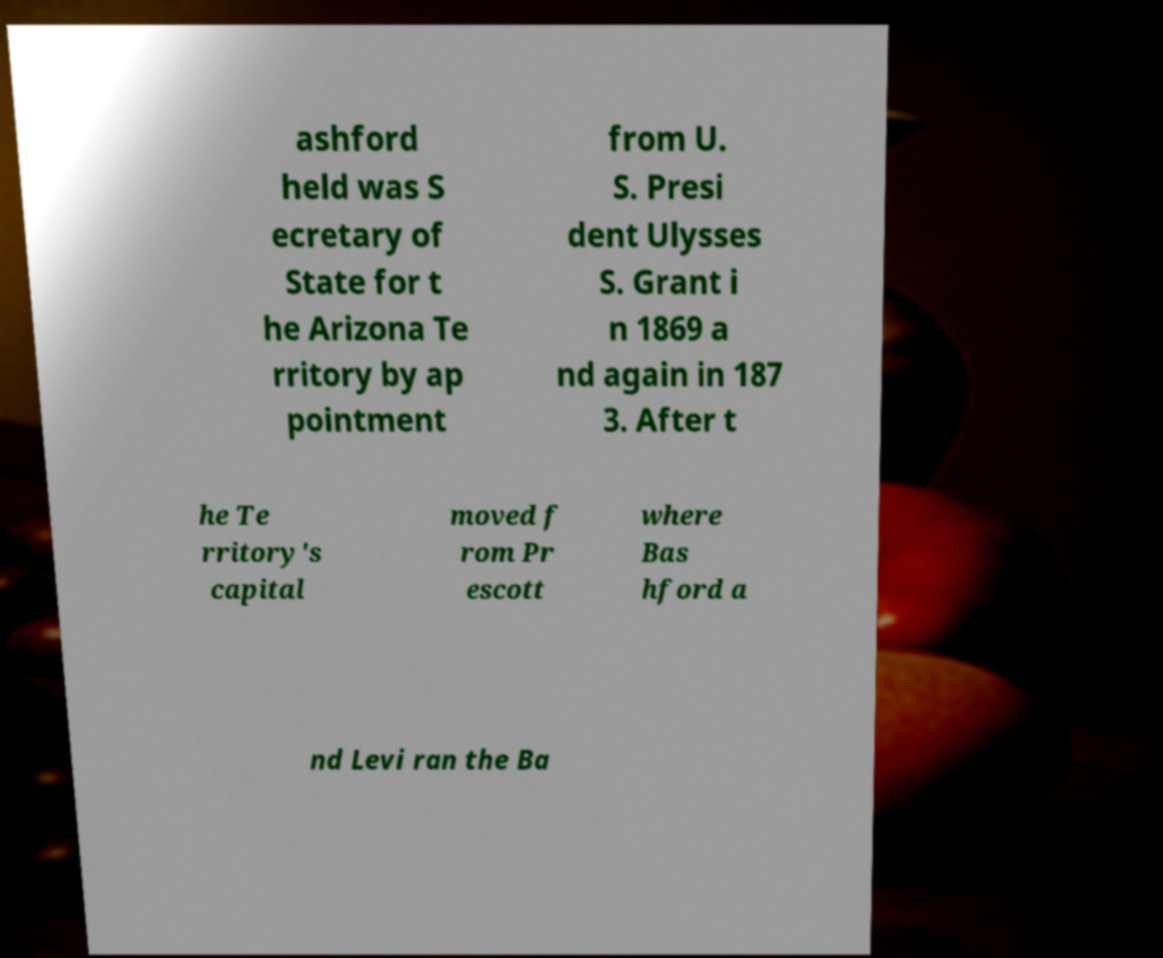Could you extract and type out the text from this image? ashford held was S ecretary of State for t he Arizona Te rritory by ap pointment from U. S. Presi dent Ulysses S. Grant i n 1869 a nd again in 187 3. After t he Te rritory's capital moved f rom Pr escott where Bas hford a nd Levi ran the Ba 